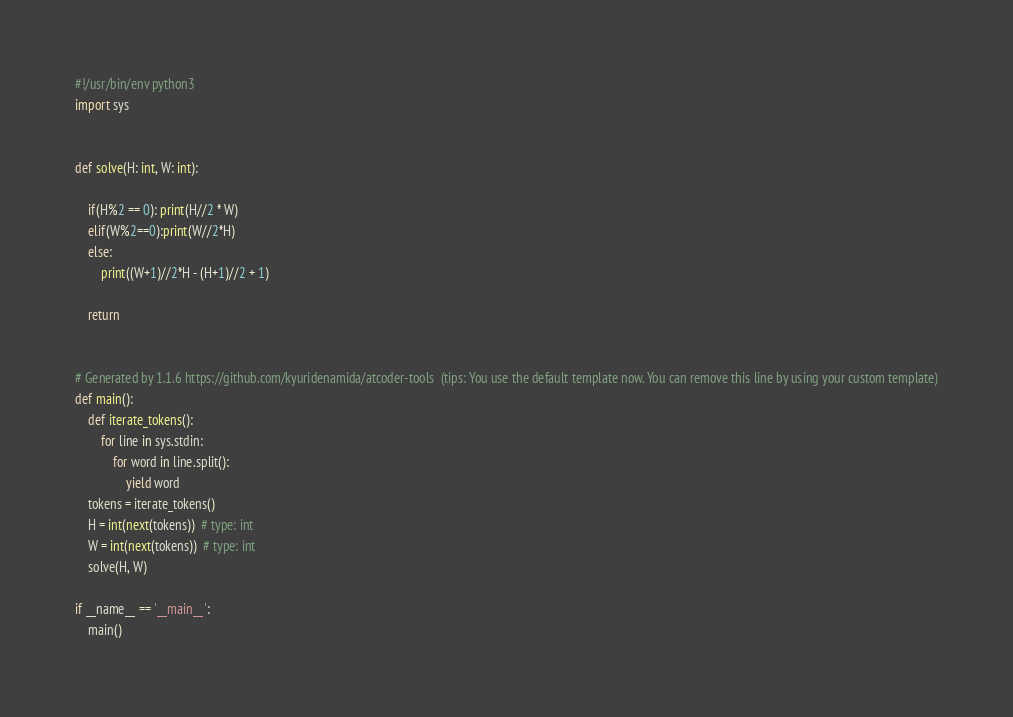<code> <loc_0><loc_0><loc_500><loc_500><_Python_>#!/usr/bin/env python3
import sys


def solve(H: int, W: int):

    if(H%2 == 0): print(H//2 * W)
    elif(W%2==0):print(W//2*H)
    else:
        print((W+1)//2*H - (H+1)//2 + 1)

    return


# Generated by 1.1.6 https://github.com/kyuridenamida/atcoder-tools  (tips: You use the default template now. You can remove this line by using your custom template)
def main():
    def iterate_tokens():
        for line in sys.stdin:
            for word in line.split():
                yield word
    tokens = iterate_tokens()
    H = int(next(tokens))  # type: int
    W = int(next(tokens))  # type: int
    solve(H, W)

if __name__ == '__main__':
    main()
</code> 